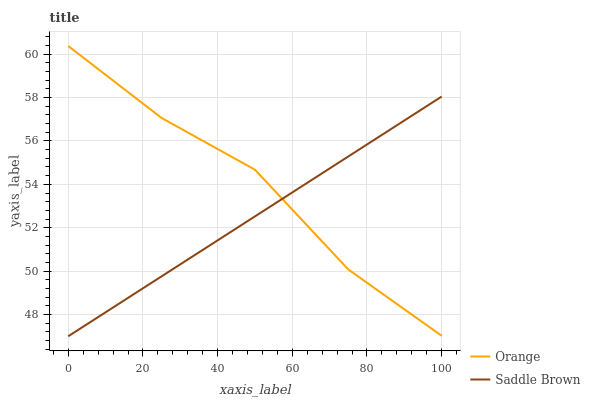Does Saddle Brown have the minimum area under the curve?
Answer yes or no. Yes. Does Orange have the maximum area under the curve?
Answer yes or no. Yes. Does Saddle Brown have the maximum area under the curve?
Answer yes or no. No. Is Saddle Brown the smoothest?
Answer yes or no. Yes. Is Orange the roughest?
Answer yes or no. Yes. Is Saddle Brown the roughest?
Answer yes or no. No. Does Saddle Brown have the lowest value?
Answer yes or no. Yes. Does Orange have the highest value?
Answer yes or no. Yes. Does Saddle Brown have the highest value?
Answer yes or no. No. Does Saddle Brown intersect Orange?
Answer yes or no. Yes. Is Saddle Brown less than Orange?
Answer yes or no. No. Is Saddle Brown greater than Orange?
Answer yes or no. No. 